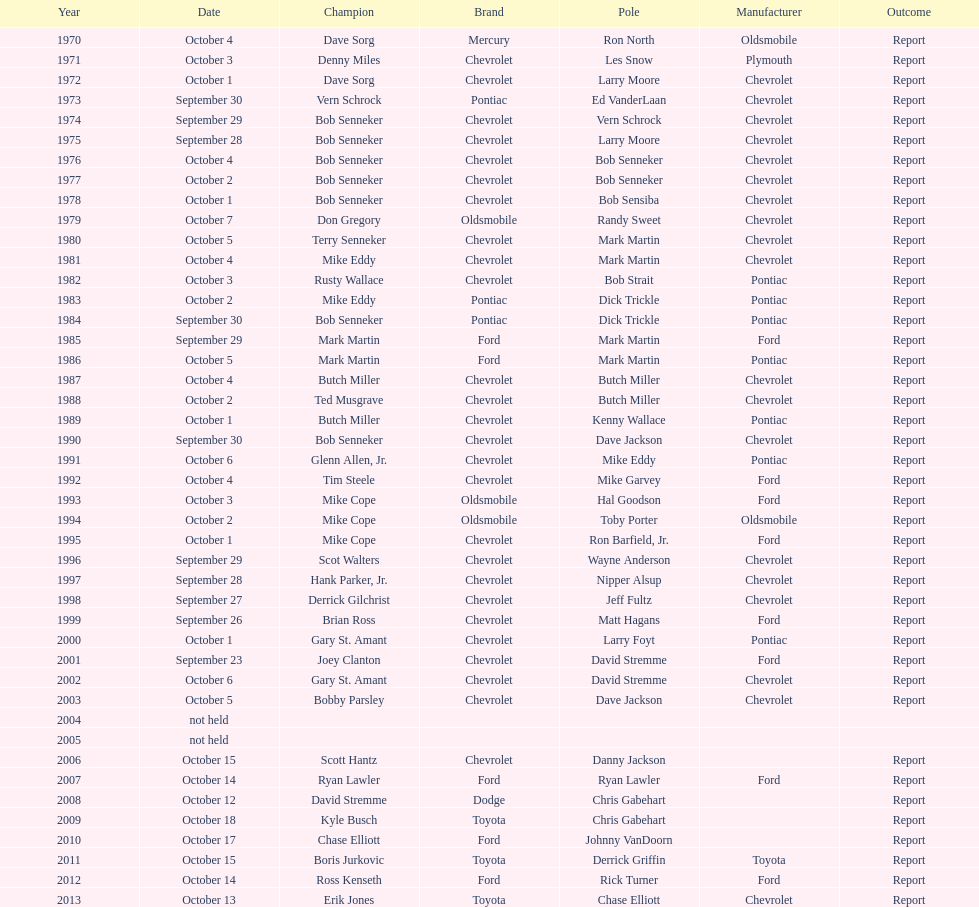How many winning oldsmobile vehicles made the list? 3. 